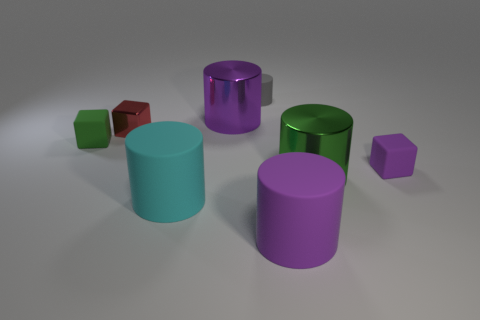What size is the cylinder that is both behind the big green metal cylinder and to the left of the tiny gray object?
Make the answer very short. Large. Is there a large green metal object that has the same shape as the small red metal thing?
Keep it short and to the point. No. What material is the big green thing that is in front of the purple shiny object that is behind the large metallic cylinder in front of the red block made of?
Provide a succinct answer. Metal. Are there any blue rubber cubes that have the same size as the gray rubber object?
Provide a short and direct response. No. The cylinder in front of the large rubber object that is to the left of the purple metal cylinder is what color?
Your answer should be very brief. Purple. How many tiny yellow cylinders are there?
Ensure brevity in your answer.  0. Is the number of small gray matte things that are to the left of the large cyan cylinder less than the number of big purple metallic objects that are on the right side of the tiny matte cylinder?
Provide a succinct answer. No. The tiny metallic cube is what color?
Provide a succinct answer. Red. Are there any purple rubber cylinders in front of the red metal block?
Provide a succinct answer. Yes. Are there an equal number of purple things that are behind the purple metallic cylinder and metallic cylinders behind the purple rubber block?
Your answer should be compact. No. 